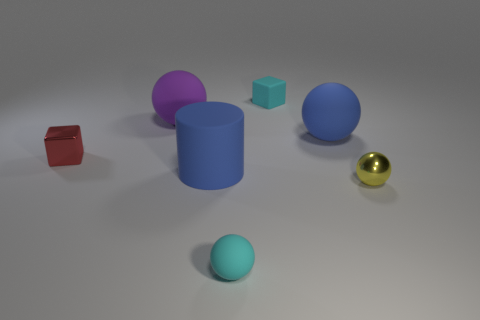The red object appears quite different from the others; what is its shape? The red object has a cubic form, adhering to a geometry that stands out due to its angularity in contrast to the rounded shapes of the balls and cylinders in the image. 